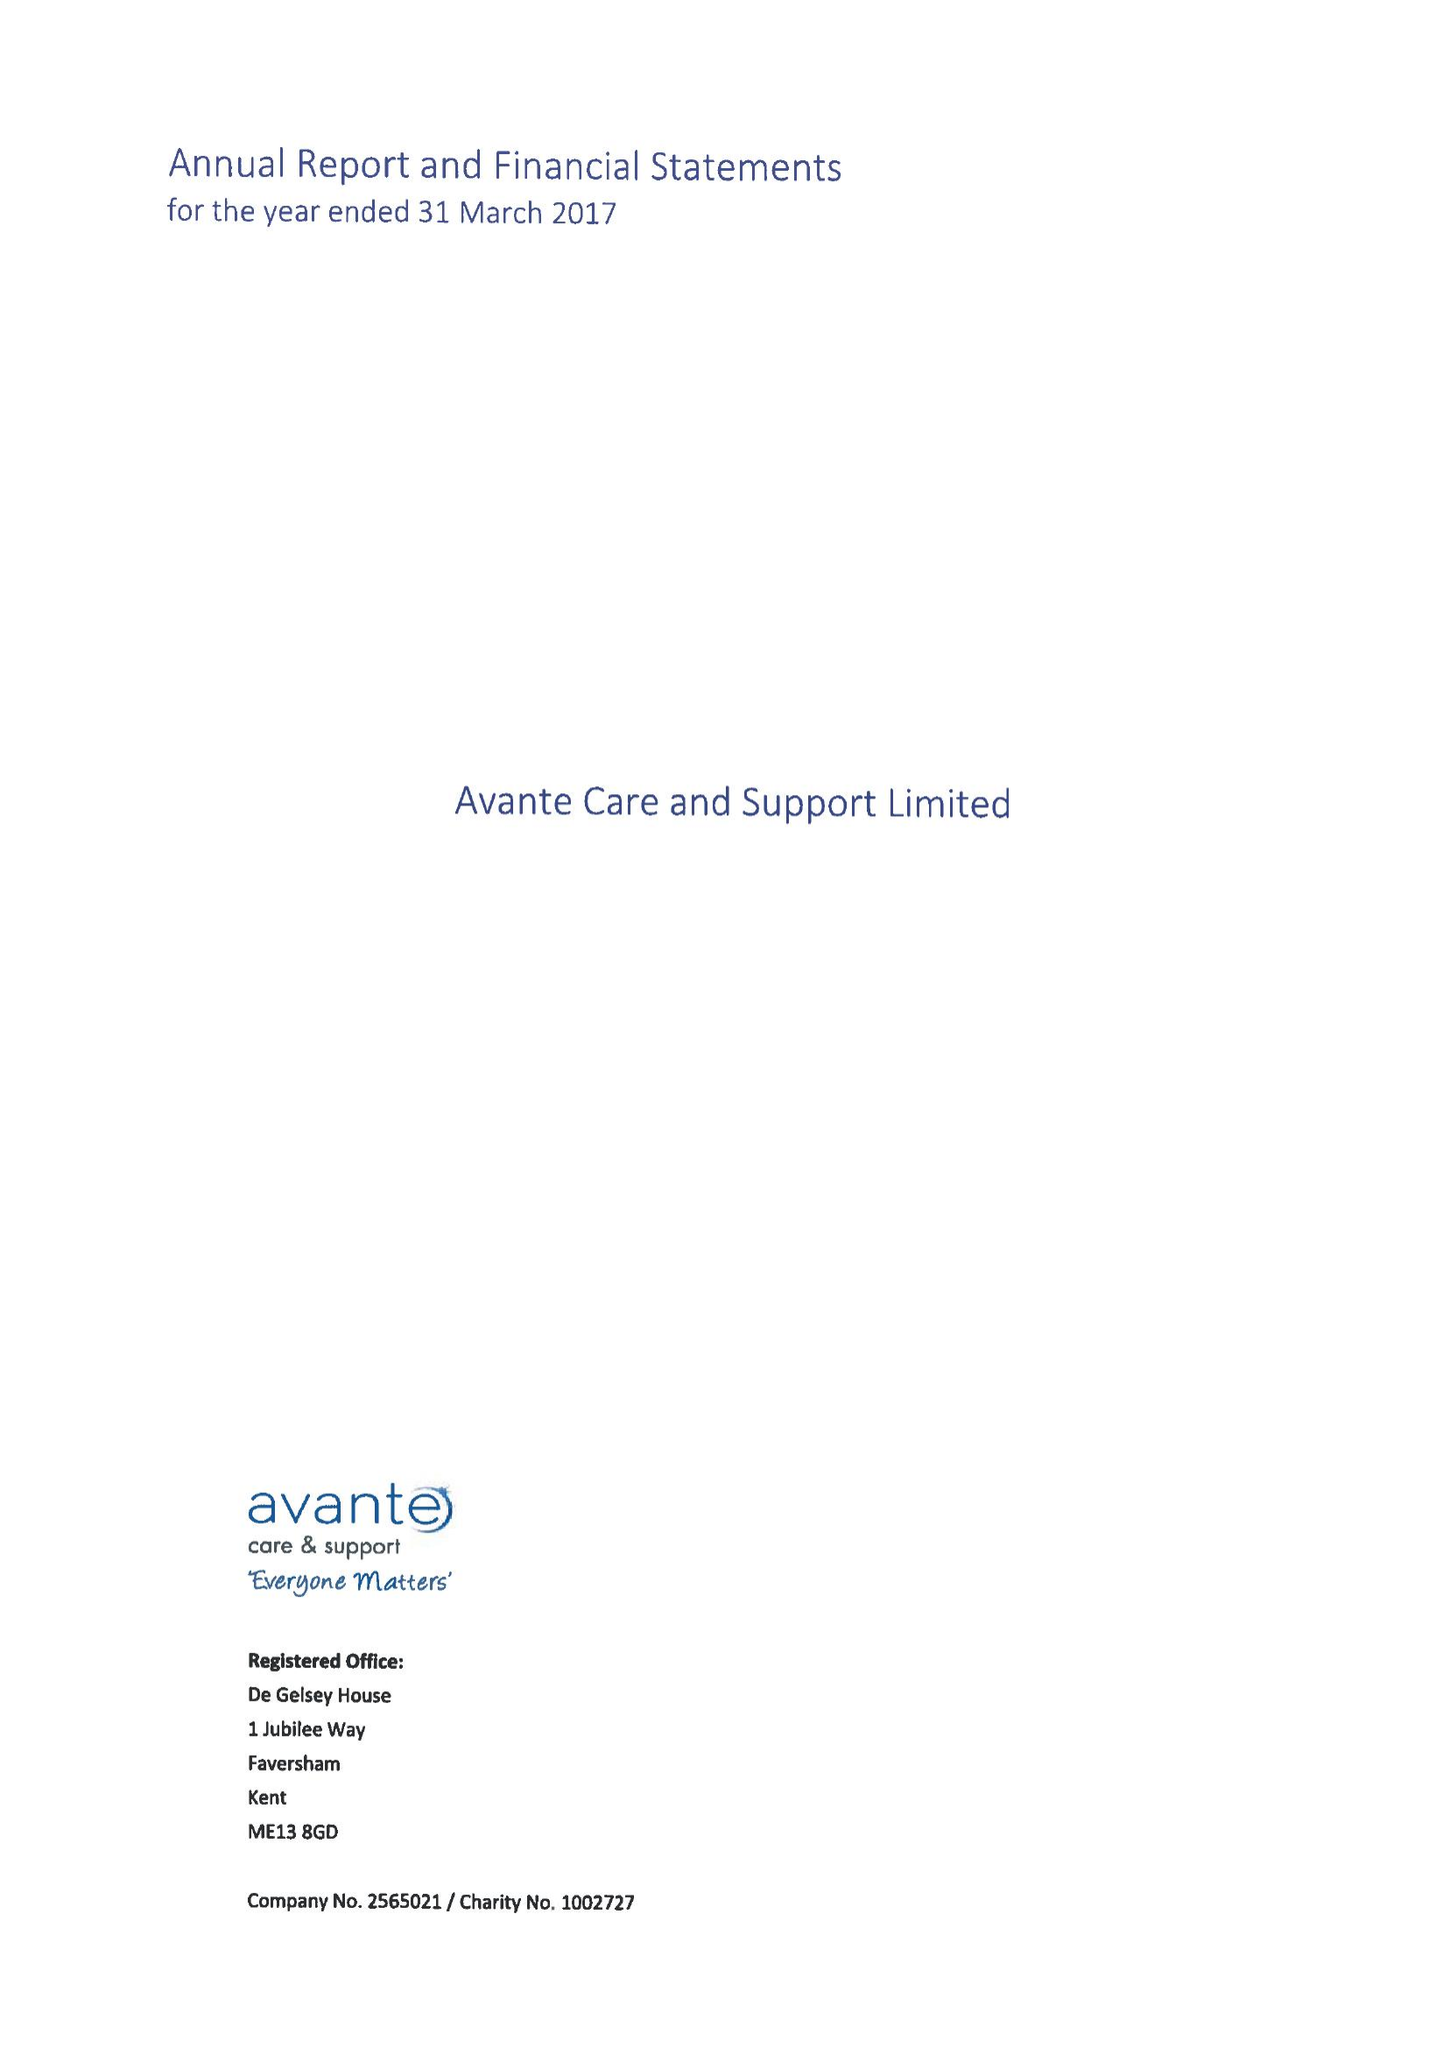What is the value for the spending_annually_in_british_pounds?
Answer the question using a single word or phrase. 23730775.00 